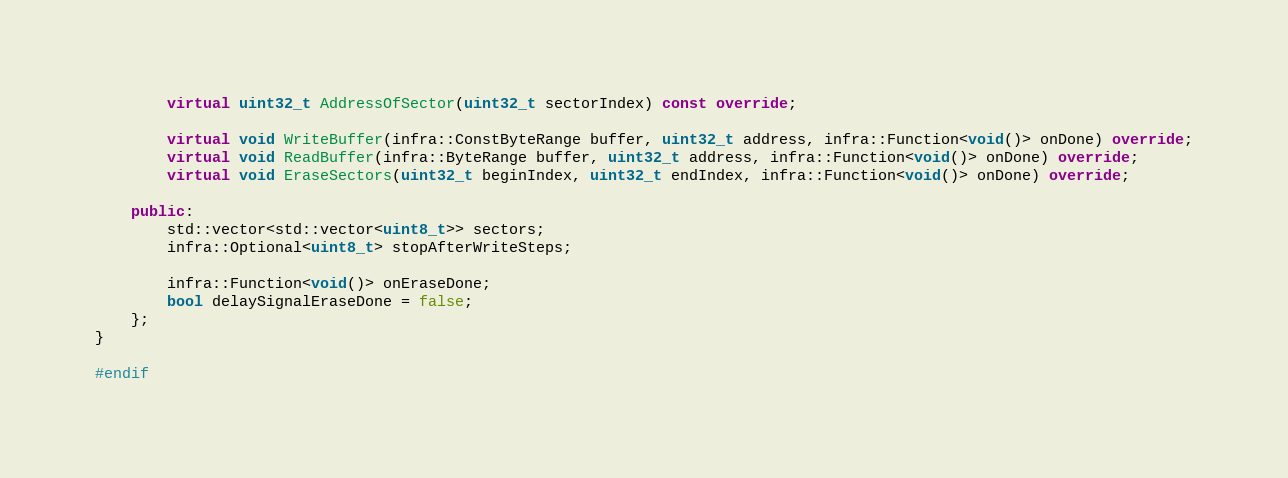<code> <loc_0><loc_0><loc_500><loc_500><_C++_>        virtual uint32_t AddressOfSector(uint32_t sectorIndex) const override;

        virtual void WriteBuffer(infra::ConstByteRange buffer, uint32_t address, infra::Function<void()> onDone) override;
        virtual void ReadBuffer(infra::ByteRange buffer, uint32_t address, infra::Function<void()> onDone) override;
        virtual void EraseSectors(uint32_t beginIndex, uint32_t endIndex, infra::Function<void()> onDone) override;

    public:
        std::vector<std::vector<uint8_t>> sectors;
        infra::Optional<uint8_t> stopAfterWriteSteps;

        infra::Function<void()> onEraseDone;
        bool delaySignalEraseDone = false;
    };
}

#endif
</code> 